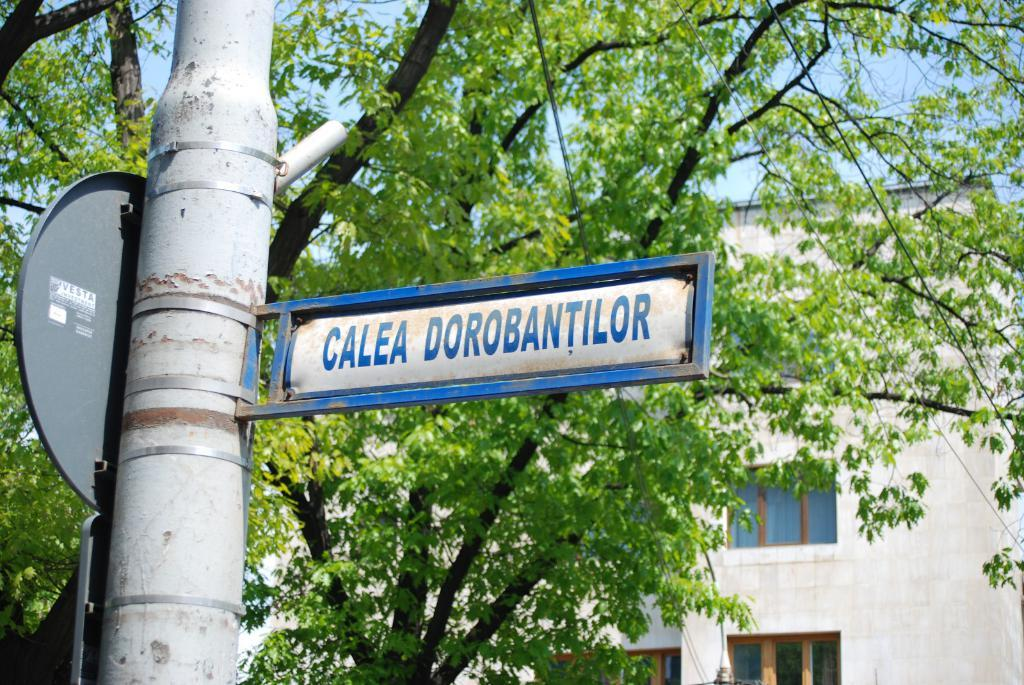<image>
Provide a brief description of the given image. A Calea Dorobantilor street sign is in front of a tree. 